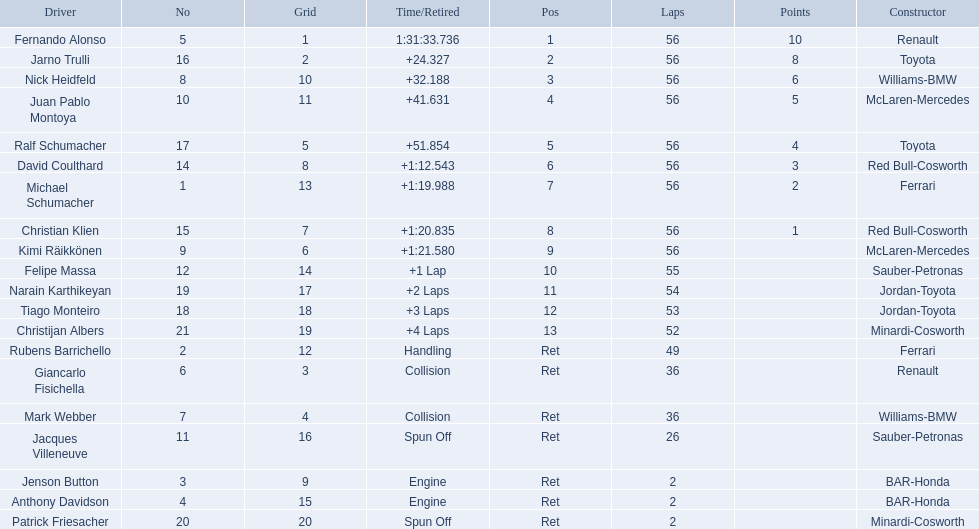What place did fernando alonso finish? 1. How long did it take alonso to finish the race? 1:31:33.736. 